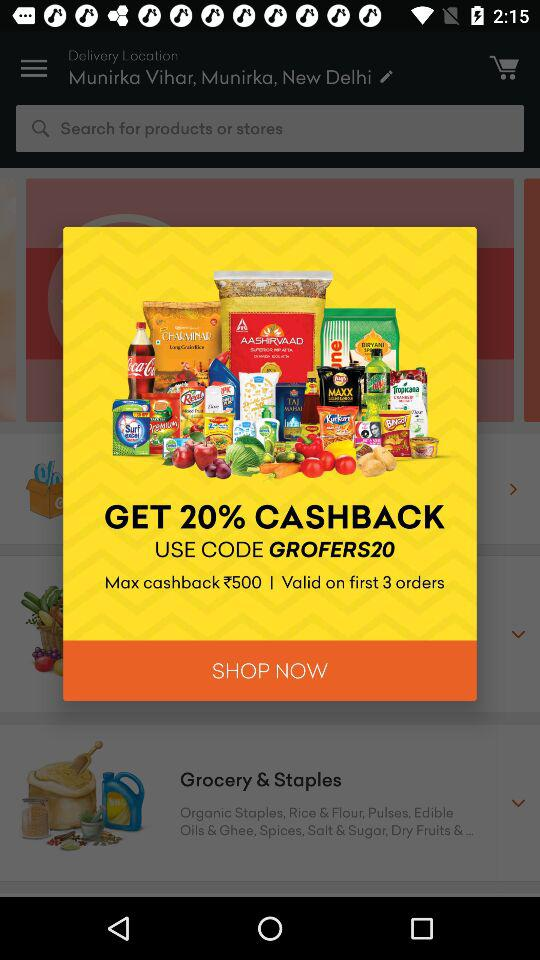How many orders can I use the code GROFERS20 on before it expires?
Answer the question using a single word or phrase. 3 